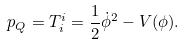<formula> <loc_0><loc_0><loc_500><loc_500>p _ { Q } = T _ { i } ^ { i } = \frac { 1 } { 2 } \dot { \phi } ^ { 2 } - V ( \phi ) .</formula> 